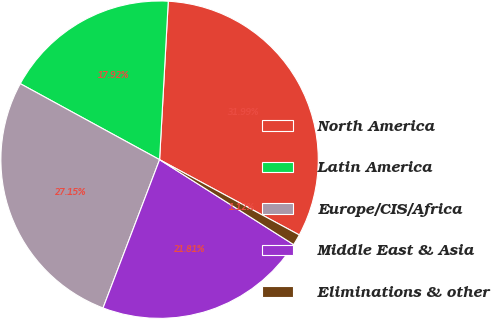Convert chart. <chart><loc_0><loc_0><loc_500><loc_500><pie_chart><fcel>North America<fcel>Latin America<fcel>Europe/CIS/Africa<fcel>Middle East & Asia<fcel>Eliminations & other<nl><fcel>31.99%<fcel>17.92%<fcel>27.15%<fcel>21.81%<fcel>1.12%<nl></chart> 